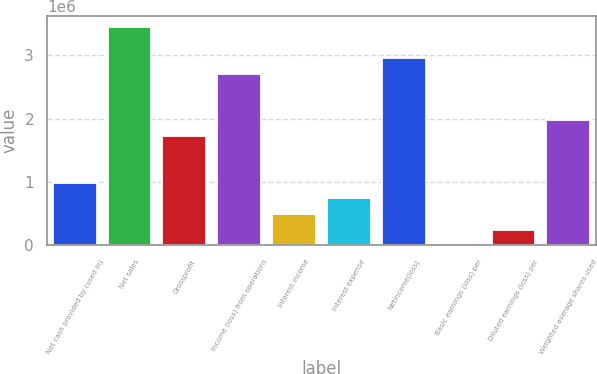Convert chart to OTSL. <chart><loc_0><loc_0><loc_500><loc_500><bar_chart><fcel>Net cash provided by (used in)<fcel>Net sales<fcel>Grossprofit<fcel>Income (loss) from operations<fcel>Interest income<fcel>Interest expense<fcel>Netincome(loss)<fcel>Basic earnings (loss) per<fcel>Diluted earnings (loss) per<fcel>Weighted average shares used<nl><fcel>986341<fcel>3.45219e+06<fcel>1.7261e+06<fcel>2.71243e+06<fcel>493172<fcel>739757<fcel>2.95902e+06<fcel>2.2<fcel>246587<fcel>1.97268e+06<nl></chart> 